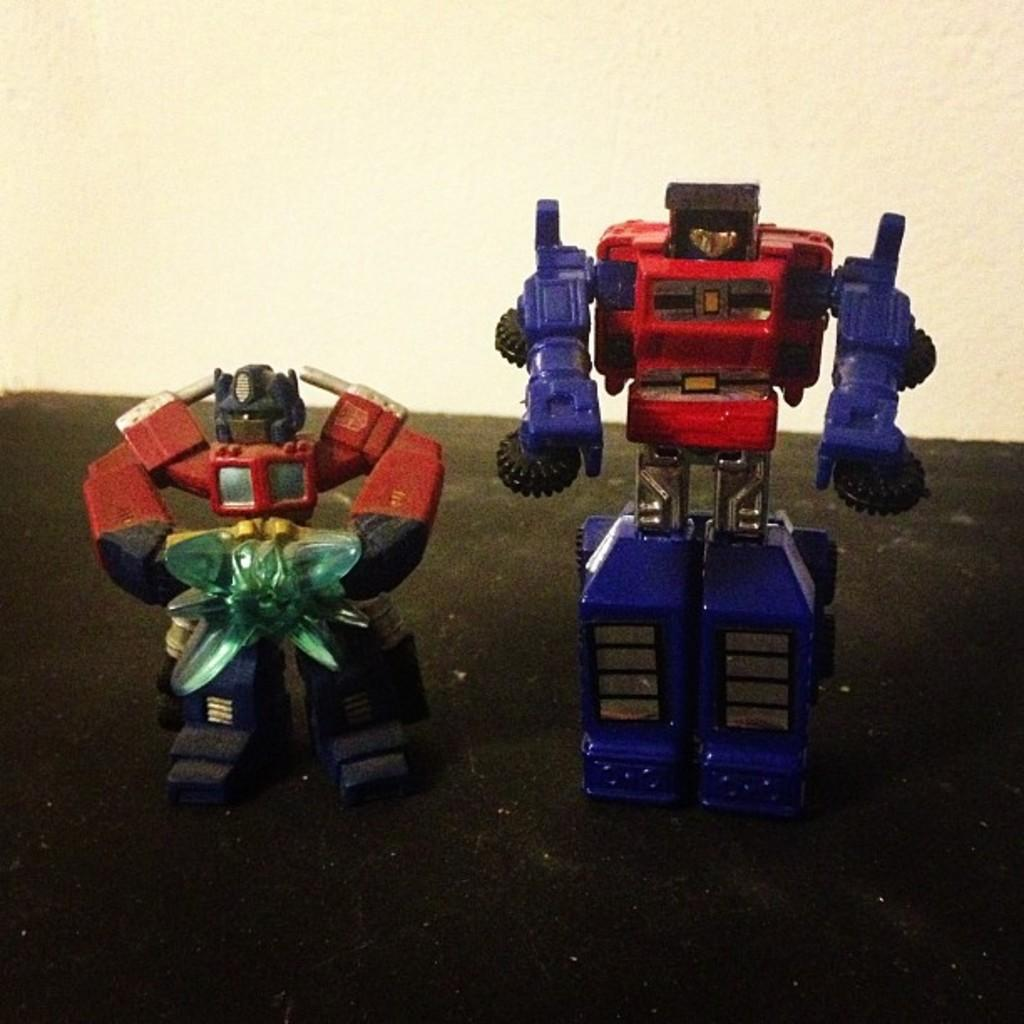What objects are on the platform in the image? There are two toys on a platform in the image. What can be seen in the background of the image? There is a wall visible in the image. What type of square cap is worn by the toy on the left in the image? There is no cap or square shape mentioned in the image; it only features two toys on a platform and a wall in the background. 